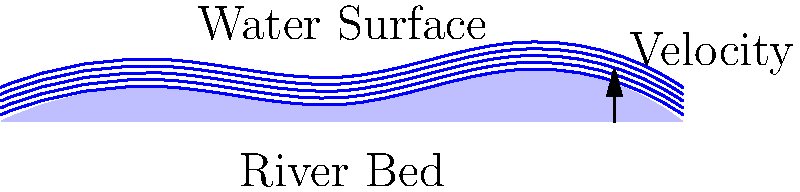Given the cross-sectional diagram of a river ecosystem, what factor primarily influences the velocity profile of the water flow, and how does this impact sediment transport and aquatic habitat? To answer this question, we need to consider the following steps:

1. Observe the velocity profile: The arrow on the right side of the diagram indicates that water velocity increases from the bottom to the top of the river.

2. Identify the primary influencing factor: The main factor affecting the velocity profile is friction between the water and the river bed. This creates a phenomenon known as the "no-slip condition" at the river bed.

3. Understand the velocity distribution:
   - Near the river bed: Velocity is lowest due to maximum friction.
   - Mid-depth: Velocity increases as the effect of bed friction decreases.
   - Near the surface: Velocity is highest, with only air resistance affecting it.

4. Impact on sediment transport:
   - Lower velocities near the bed allow for sediment deposition.
   - Higher velocities in the upper layers can carry suspended sediments.
   - The variation in velocity creates a dynamic equilibrium of erosion and deposition.

5. Effect on aquatic habitat:
   - Slow-moving areas near the bed provide refuge for some aquatic organisms.
   - Faster-moving areas supply oxygen and nutrients.
   - The varied flow creates diverse microhabitats supporting different species.

The velocity profile, primarily influenced by bed friction, creates a complex ecosystem that balances sediment transport and provides diverse aquatic habitats.
Answer: Bed friction creates a velocity gradient, influencing sediment distribution and habitat diversity. 